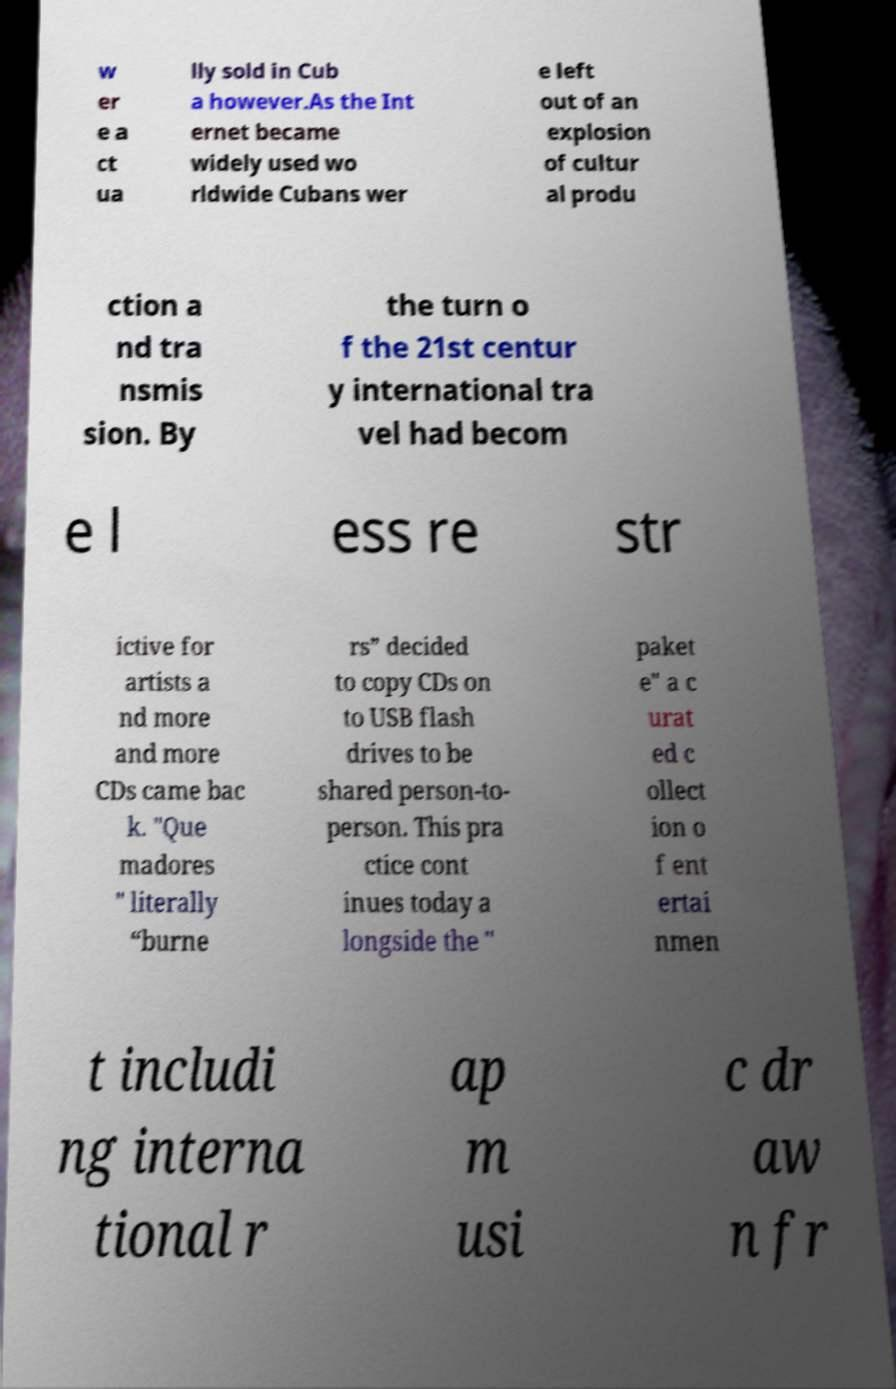Please identify and transcribe the text found in this image. w er e a ct ua lly sold in Cub a however.As the Int ernet became widely used wo rldwide Cubans wer e left out of an explosion of cultur al produ ction a nd tra nsmis sion. By the turn o f the 21st centur y international tra vel had becom e l ess re str ictive for artists a nd more and more CDs came bac k. "Que madores " literally “burne rs” decided to copy CDs on to USB flash drives to be shared person-to- person. This pra ctice cont inues today a longside the " paket e" a c urat ed c ollect ion o f ent ertai nmen t includi ng interna tional r ap m usi c dr aw n fr 